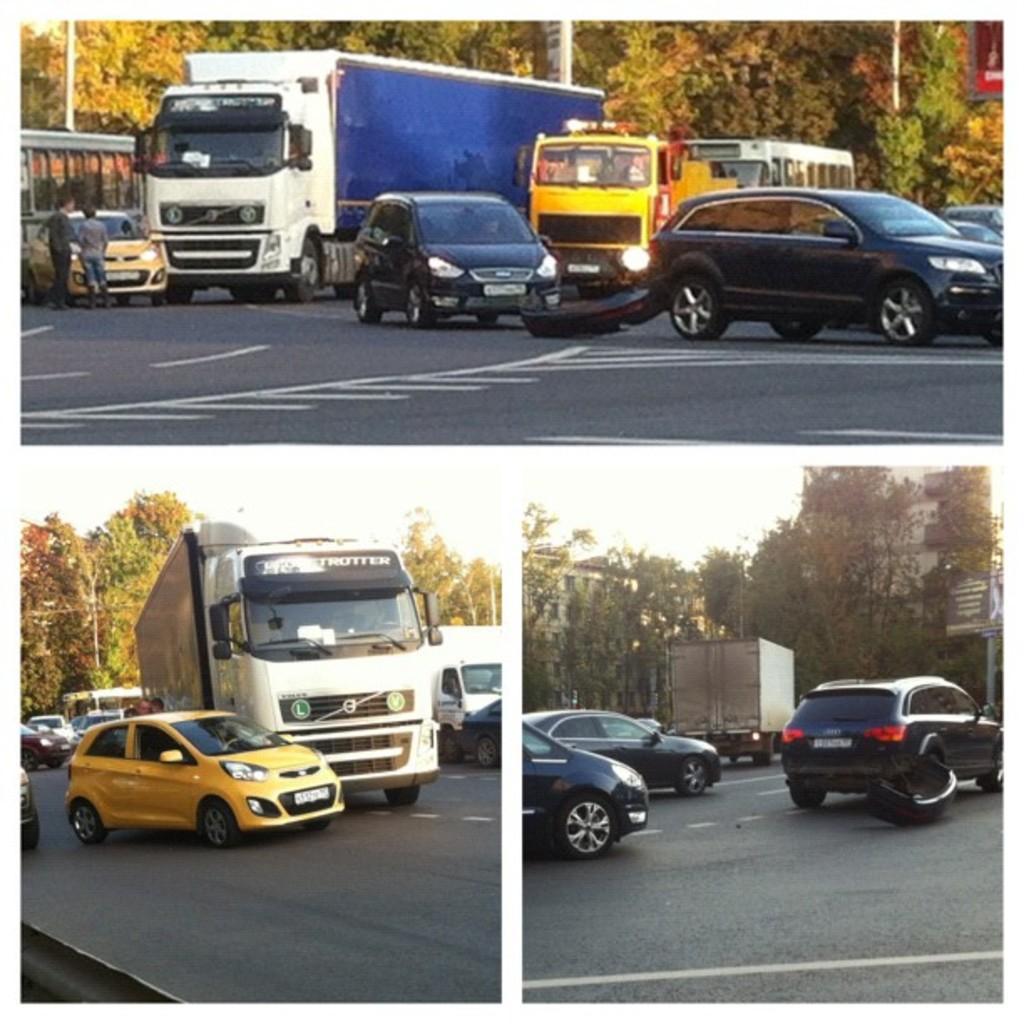Can you describe this image briefly? This image looks like an edited photo in which I can see fleets of vehicles on the road, trees, buildings, light poles, boards and the sky. This image is taken, may be during a day. 